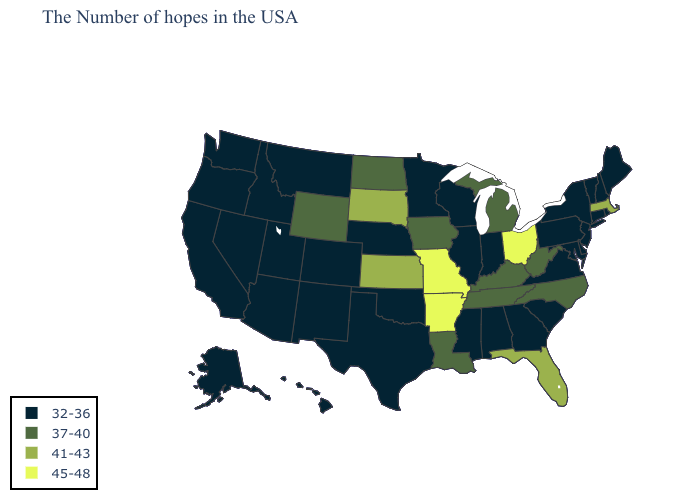What is the highest value in the USA?
Be succinct. 45-48. Does the map have missing data?
Answer briefly. No. What is the value of Kentucky?
Be succinct. 37-40. What is the value of Oregon?
Keep it brief. 32-36. Among the states that border Idaho , does Wyoming have the highest value?
Answer briefly. Yes. Among the states that border Minnesota , does Iowa have the lowest value?
Short answer required. No. Does the first symbol in the legend represent the smallest category?
Answer briefly. Yes. Name the states that have a value in the range 41-43?
Be succinct. Massachusetts, Florida, Kansas, South Dakota. What is the lowest value in the USA?
Quick response, please. 32-36. Name the states that have a value in the range 32-36?
Keep it brief. Maine, Rhode Island, New Hampshire, Vermont, Connecticut, New York, New Jersey, Delaware, Maryland, Pennsylvania, Virginia, South Carolina, Georgia, Indiana, Alabama, Wisconsin, Illinois, Mississippi, Minnesota, Nebraska, Oklahoma, Texas, Colorado, New Mexico, Utah, Montana, Arizona, Idaho, Nevada, California, Washington, Oregon, Alaska, Hawaii. What is the value of Oklahoma?
Write a very short answer. 32-36. Does Washington have the highest value in the USA?
Give a very brief answer. No. Among the states that border Virginia , which have the highest value?
Be succinct. North Carolina, West Virginia, Kentucky, Tennessee. What is the value of North Carolina?
Quick response, please. 37-40. 